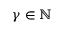Convert formula to latex. <formula><loc_0><loc_0><loc_500><loc_500>\gamma \in \mathbb { N }</formula> 